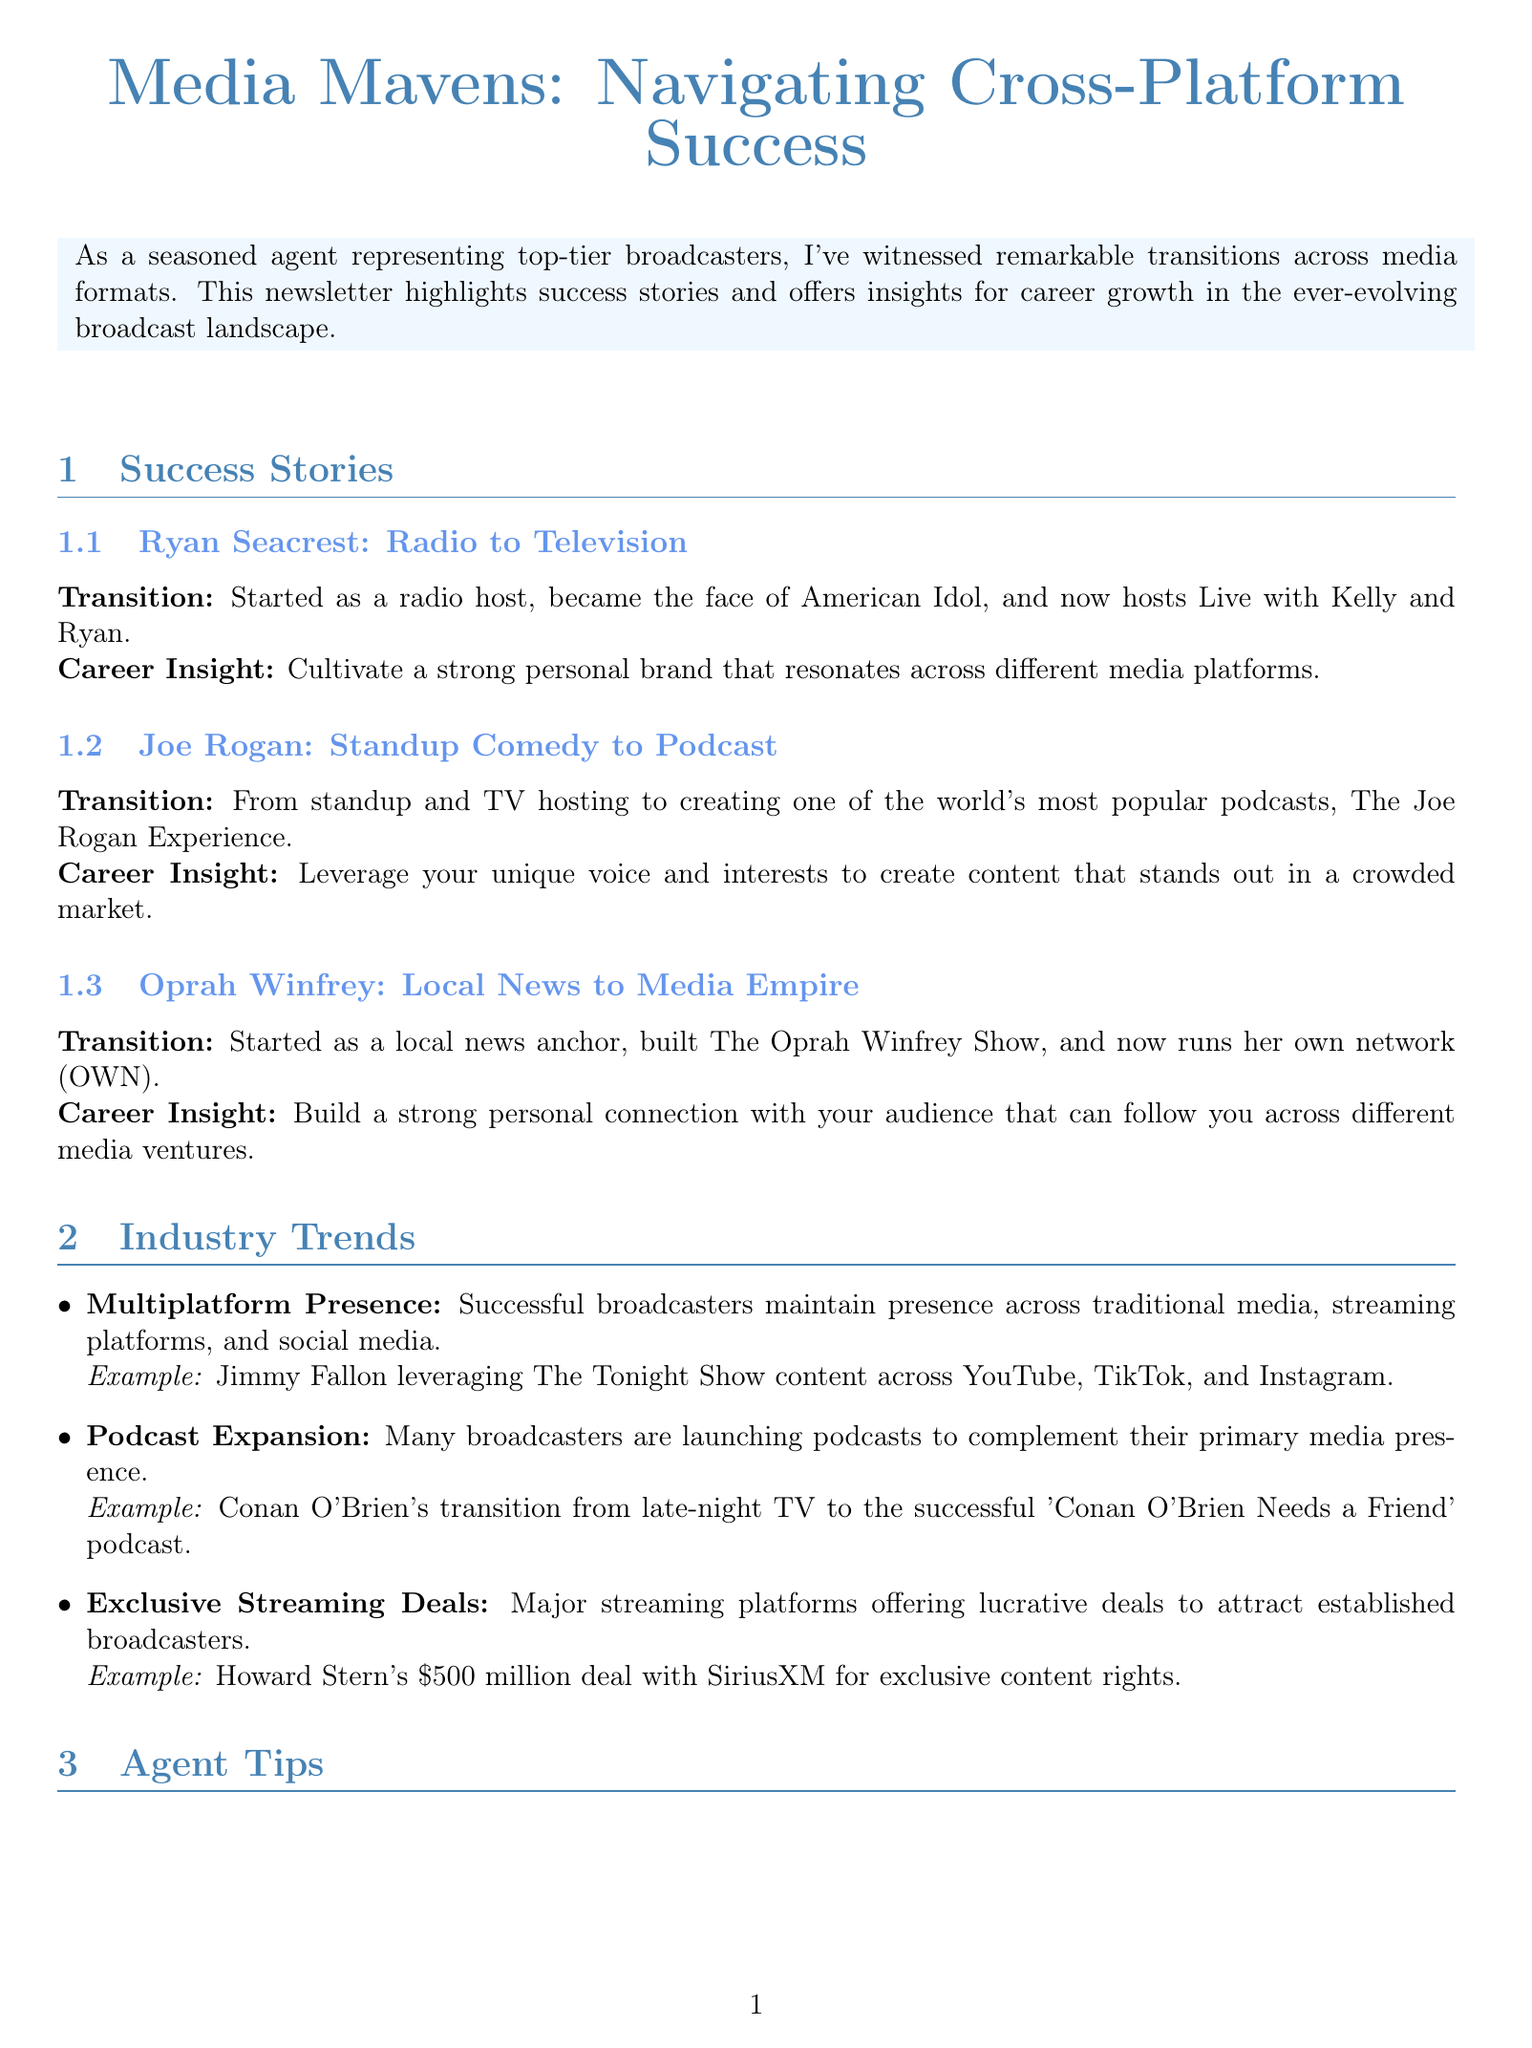What is the title of the newsletter? The title of the newsletter is indicated at the top of the document.
Answer: Media Mavens: Navigating Cross-Platform Success Who is featured for the transition from radio to television? The document lists several success stories, one of which transitions from radio to television.
Answer: Ryan Seacrest What is Joe Rogan known for transitioning into? The success story mentions Joe Rogan's new media format that he transitioned into.
Answer: Podcast What must broadcasters build to connect with their audience according to Oprah Winfrey's insight? Oprah's career insight emphasizes an important aspect of audience engagement.
Answer: Strong personal connection What is a trend mentioned in the industry trends section? The document outlines several trends; one is highlighted in the specific section.
Answer: Podcast Expansion What kind of partnerships should agents build? The agent tips provide a specific strategy regarding the relationships that should be nurtured.
Answer: Strategic Partnerships How much was Howard Stern's deal worth with SiriusXM? The document specifies the financial details of a major exclusive deal in the industry.
Answer: $500 million What should agents negotiate for in contracts? The tips section advises agents regarding rights in deals.
Answer: Cross-Platform Rights 